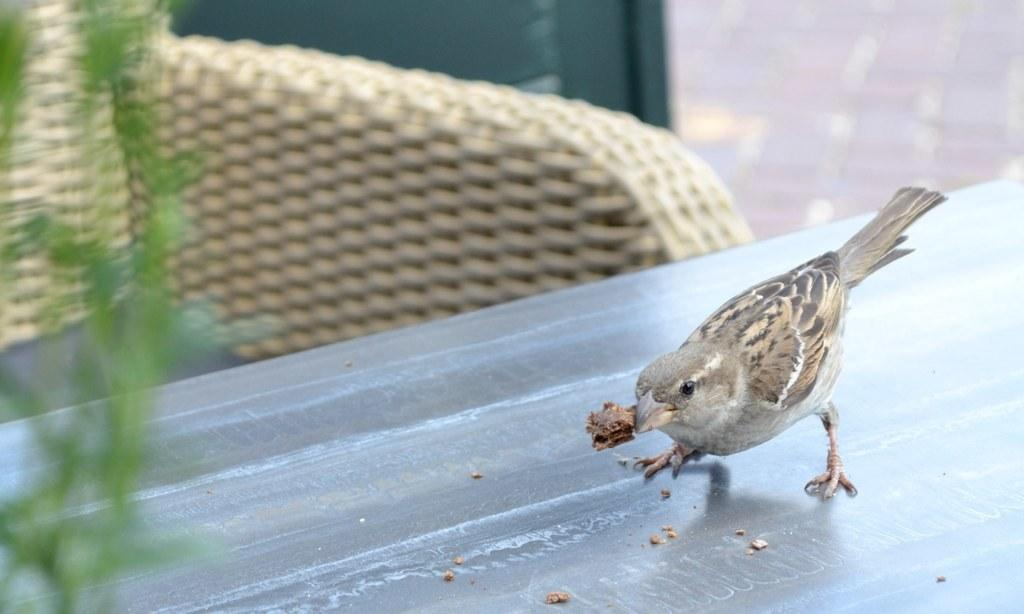What type of animal is in the image? There is a bird in the image. Can you describe the bird's colors? The bird has white, brown, and black colors. What is the bird standing on in the image? The bird is on a grey surface. What type of plant can be seen in the image? There is a green plant in the image. What is the color of the cream-colored object in the image? The cream-colored object in the image is, well, cream-colored. How does the bird tie a knot in the image? The bird does not tie a knot in the image; it is simply standing on a grey surface. What type of sack is present in the image? There is no sack present in the image. 